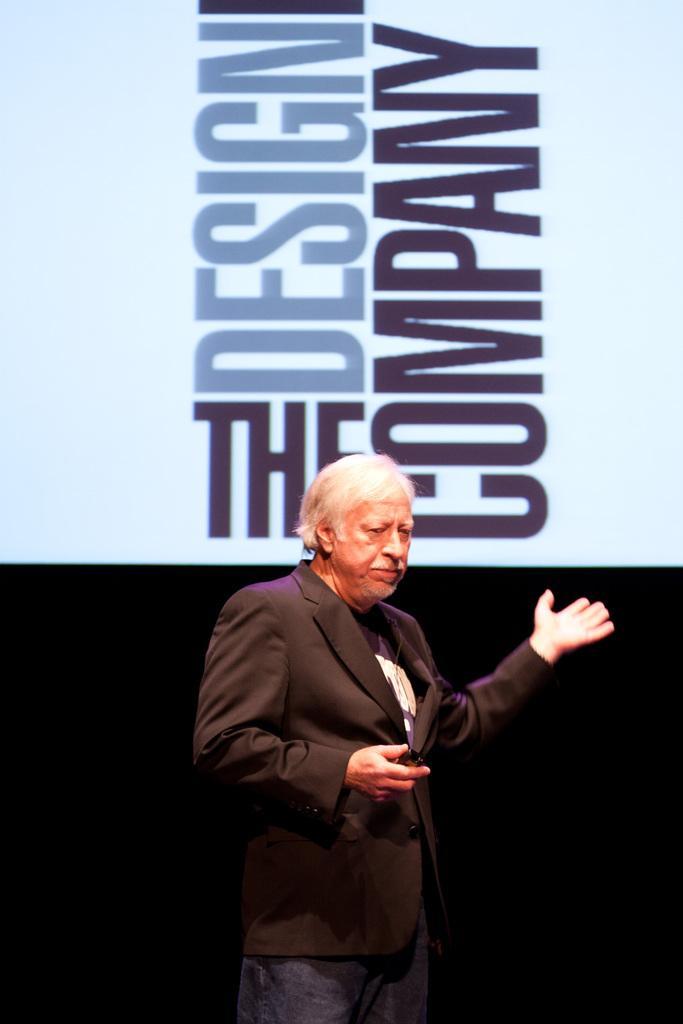Please provide a concise description of this image. The man in the middle of the picture wearing black blazer is holding something in his hand and he is trying to explain something. Behind him, we see a white board with some text written on it. Behind him, it is black in color. 